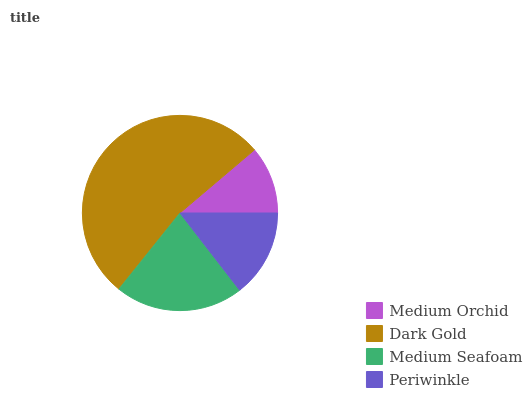Is Medium Orchid the minimum?
Answer yes or no. Yes. Is Dark Gold the maximum?
Answer yes or no. Yes. Is Medium Seafoam the minimum?
Answer yes or no. No. Is Medium Seafoam the maximum?
Answer yes or no. No. Is Dark Gold greater than Medium Seafoam?
Answer yes or no. Yes. Is Medium Seafoam less than Dark Gold?
Answer yes or no. Yes. Is Medium Seafoam greater than Dark Gold?
Answer yes or no. No. Is Dark Gold less than Medium Seafoam?
Answer yes or no. No. Is Medium Seafoam the high median?
Answer yes or no. Yes. Is Periwinkle the low median?
Answer yes or no. Yes. Is Periwinkle the high median?
Answer yes or no. No. Is Medium Orchid the low median?
Answer yes or no. No. 